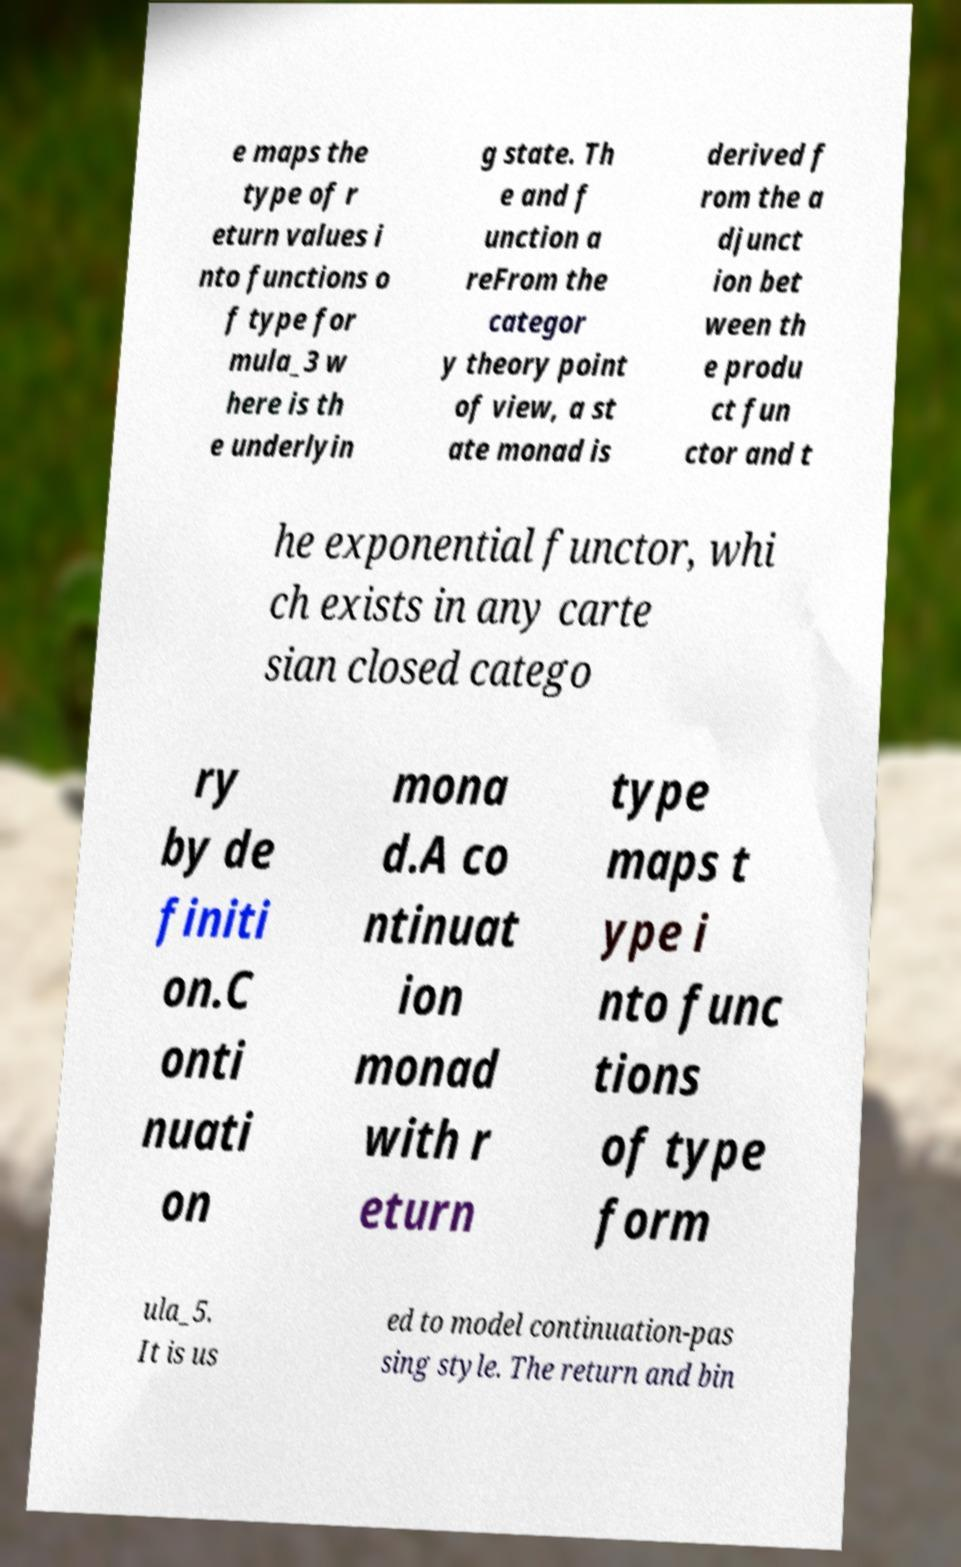Could you assist in decoding the text presented in this image and type it out clearly? e maps the type of r eturn values i nto functions o f type for mula_3 w here is th e underlyin g state. Th e and f unction a reFrom the categor y theory point of view, a st ate monad is derived f rom the a djunct ion bet ween th e produ ct fun ctor and t he exponential functor, whi ch exists in any carte sian closed catego ry by de finiti on.C onti nuati on mona d.A co ntinuat ion monad with r eturn type maps t ype i nto func tions of type form ula_5. It is us ed to model continuation-pas sing style. The return and bin 